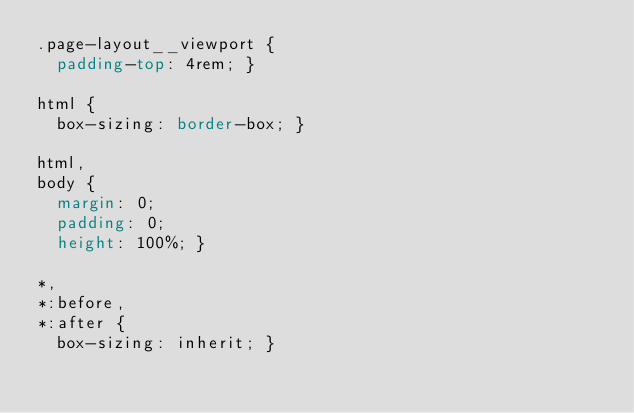Convert code to text. <code><loc_0><loc_0><loc_500><loc_500><_CSS_>.page-layout__viewport {
  padding-top: 4rem; }

html {
  box-sizing: border-box; }

html,
body {
  margin: 0;
  padding: 0;
  height: 100%; }

*,
*:before,
*:after {
  box-sizing: inherit; }
</code> 